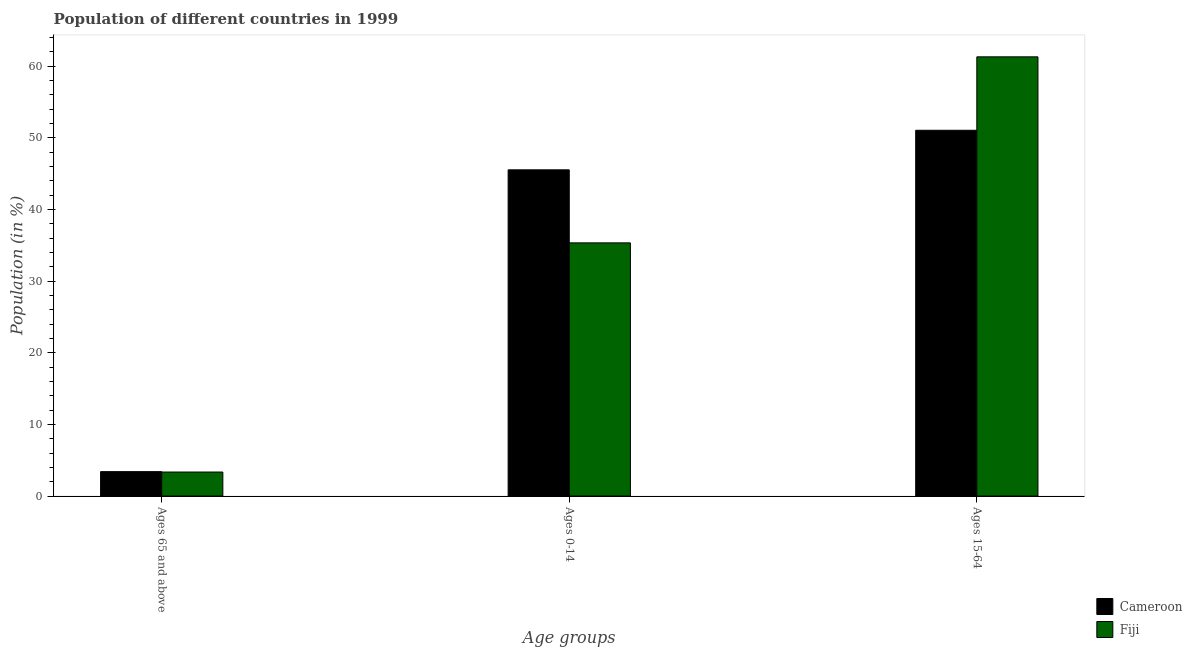Are the number of bars per tick equal to the number of legend labels?
Provide a short and direct response. Yes. How many bars are there on the 3rd tick from the left?
Your response must be concise. 2. What is the label of the 2nd group of bars from the left?
Make the answer very short. Ages 0-14. What is the percentage of population within the age-group 15-64 in Fiji?
Your answer should be compact. 61.31. Across all countries, what is the maximum percentage of population within the age-group 15-64?
Ensure brevity in your answer.  61.31. Across all countries, what is the minimum percentage of population within the age-group 15-64?
Your answer should be compact. 51.06. In which country was the percentage of population within the age-group of 65 and above maximum?
Provide a short and direct response. Cameroon. In which country was the percentage of population within the age-group 15-64 minimum?
Your answer should be very brief. Cameroon. What is the total percentage of population within the age-group 0-14 in the graph?
Keep it short and to the point. 80.87. What is the difference between the percentage of population within the age-group 0-14 in Fiji and that in Cameroon?
Offer a terse response. -10.19. What is the difference between the percentage of population within the age-group of 65 and above in Fiji and the percentage of population within the age-group 15-64 in Cameroon?
Offer a terse response. -47.7. What is the average percentage of population within the age-group 0-14 per country?
Offer a very short reply. 40.44. What is the difference between the percentage of population within the age-group 0-14 and percentage of population within the age-group of 65 and above in Cameroon?
Your answer should be compact. 42.12. What is the ratio of the percentage of population within the age-group of 65 and above in Cameroon to that in Fiji?
Give a very brief answer. 1.02. Is the percentage of population within the age-group 0-14 in Fiji less than that in Cameroon?
Keep it short and to the point. Yes. Is the difference between the percentage of population within the age-group 15-64 in Fiji and Cameroon greater than the difference between the percentage of population within the age-group 0-14 in Fiji and Cameroon?
Ensure brevity in your answer.  Yes. What is the difference between the highest and the second highest percentage of population within the age-group of 65 and above?
Make the answer very short. 0.06. What is the difference between the highest and the lowest percentage of population within the age-group 15-64?
Provide a succinct answer. 10.25. In how many countries, is the percentage of population within the age-group of 65 and above greater than the average percentage of population within the age-group of 65 and above taken over all countries?
Offer a terse response. 1. What does the 2nd bar from the left in Ages 65 and above represents?
Your answer should be compact. Fiji. What does the 1st bar from the right in Ages 0-14 represents?
Ensure brevity in your answer.  Fiji. How many bars are there?
Keep it short and to the point. 6. Are all the bars in the graph horizontal?
Your response must be concise. No. How many countries are there in the graph?
Keep it short and to the point. 2. Are the values on the major ticks of Y-axis written in scientific E-notation?
Make the answer very short. No. Does the graph contain any zero values?
Your response must be concise. No. Where does the legend appear in the graph?
Make the answer very short. Bottom right. What is the title of the graph?
Offer a very short reply. Population of different countries in 1999. Does "Comoros" appear as one of the legend labels in the graph?
Make the answer very short. No. What is the label or title of the X-axis?
Offer a terse response. Age groups. What is the Population (in %) in Cameroon in Ages 65 and above?
Make the answer very short. 3.41. What is the Population (in %) in Fiji in Ages 65 and above?
Offer a terse response. 3.35. What is the Population (in %) of Cameroon in Ages 0-14?
Keep it short and to the point. 45.53. What is the Population (in %) in Fiji in Ages 0-14?
Offer a terse response. 35.34. What is the Population (in %) in Cameroon in Ages 15-64?
Make the answer very short. 51.06. What is the Population (in %) in Fiji in Ages 15-64?
Make the answer very short. 61.31. Across all Age groups, what is the maximum Population (in %) in Cameroon?
Your response must be concise. 51.06. Across all Age groups, what is the maximum Population (in %) of Fiji?
Ensure brevity in your answer.  61.31. Across all Age groups, what is the minimum Population (in %) in Cameroon?
Keep it short and to the point. 3.41. Across all Age groups, what is the minimum Population (in %) in Fiji?
Your answer should be compact. 3.35. What is the difference between the Population (in %) of Cameroon in Ages 65 and above and that in Ages 0-14?
Ensure brevity in your answer.  -42.12. What is the difference between the Population (in %) of Fiji in Ages 65 and above and that in Ages 0-14?
Your answer should be very brief. -31.99. What is the difference between the Population (in %) of Cameroon in Ages 65 and above and that in Ages 15-64?
Your answer should be compact. -47.65. What is the difference between the Population (in %) in Fiji in Ages 65 and above and that in Ages 15-64?
Your answer should be compact. -57.95. What is the difference between the Population (in %) in Cameroon in Ages 0-14 and that in Ages 15-64?
Your answer should be very brief. -5.52. What is the difference between the Population (in %) of Fiji in Ages 0-14 and that in Ages 15-64?
Make the answer very short. -25.97. What is the difference between the Population (in %) of Cameroon in Ages 65 and above and the Population (in %) of Fiji in Ages 0-14?
Make the answer very short. -31.93. What is the difference between the Population (in %) in Cameroon in Ages 65 and above and the Population (in %) in Fiji in Ages 15-64?
Make the answer very short. -57.9. What is the difference between the Population (in %) in Cameroon in Ages 0-14 and the Population (in %) in Fiji in Ages 15-64?
Your answer should be very brief. -15.77. What is the average Population (in %) in Cameroon per Age groups?
Provide a short and direct response. 33.33. What is the average Population (in %) in Fiji per Age groups?
Offer a terse response. 33.33. What is the difference between the Population (in %) of Cameroon and Population (in %) of Fiji in Ages 65 and above?
Give a very brief answer. 0.06. What is the difference between the Population (in %) of Cameroon and Population (in %) of Fiji in Ages 0-14?
Offer a terse response. 10.19. What is the difference between the Population (in %) of Cameroon and Population (in %) of Fiji in Ages 15-64?
Your response must be concise. -10.25. What is the ratio of the Population (in %) in Cameroon in Ages 65 and above to that in Ages 0-14?
Provide a short and direct response. 0.07. What is the ratio of the Population (in %) of Fiji in Ages 65 and above to that in Ages 0-14?
Provide a short and direct response. 0.09. What is the ratio of the Population (in %) in Cameroon in Ages 65 and above to that in Ages 15-64?
Your answer should be very brief. 0.07. What is the ratio of the Population (in %) of Fiji in Ages 65 and above to that in Ages 15-64?
Offer a very short reply. 0.05. What is the ratio of the Population (in %) in Cameroon in Ages 0-14 to that in Ages 15-64?
Offer a very short reply. 0.89. What is the ratio of the Population (in %) in Fiji in Ages 0-14 to that in Ages 15-64?
Offer a terse response. 0.58. What is the difference between the highest and the second highest Population (in %) in Cameroon?
Ensure brevity in your answer.  5.52. What is the difference between the highest and the second highest Population (in %) in Fiji?
Ensure brevity in your answer.  25.97. What is the difference between the highest and the lowest Population (in %) of Cameroon?
Your answer should be compact. 47.65. What is the difference between the highest and the lowest Population (in %) in Fiji?
Your response must be concise. 57.95. 